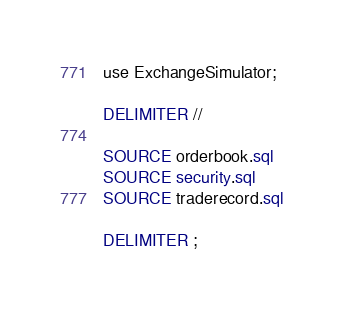<code> <loc_0><loc_0><loc_500><loc_500><_SQL_>use ExchangeSimulator;

DELIMITER //

SOURCE orderbook.sql
SOURCE security.sql
SOURCE traderecord.sql

DELIMITER ;
</code> 